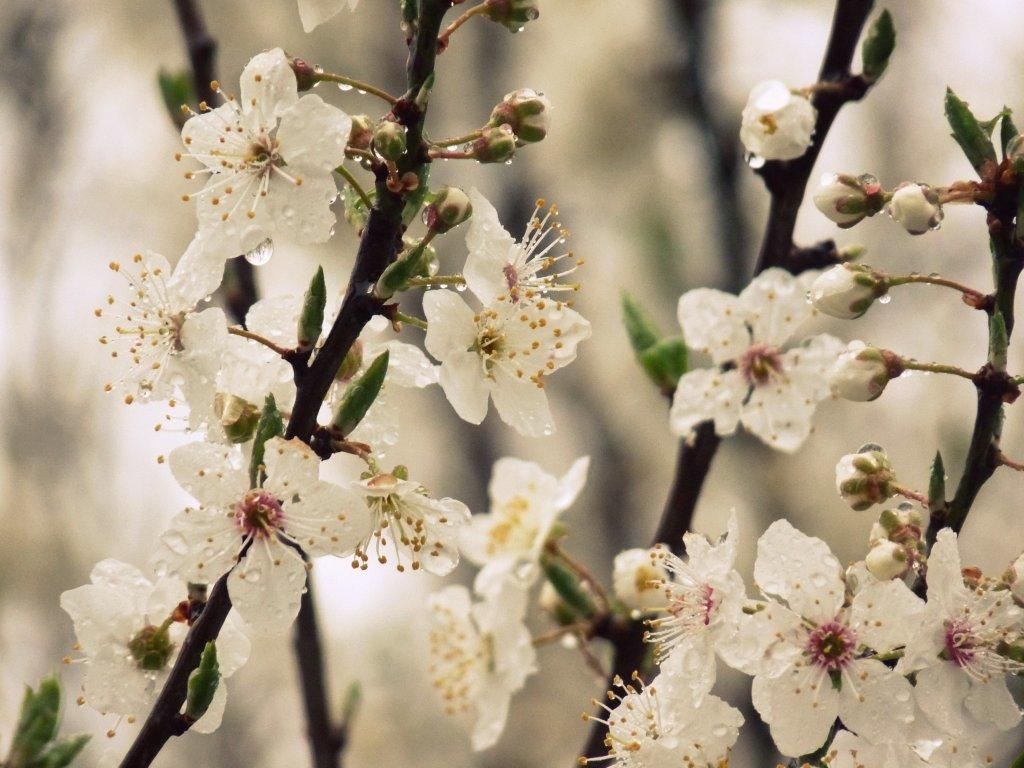What type of plant life is visible in the image? There are flowers and leaves in the image. Are there any unopened flowers in the image? Yes, there are buds on the stems in the image. What direction are the flowers facing in the image? The flowers' direction cannot be determined from the image, as they are not facing a specific direction. 